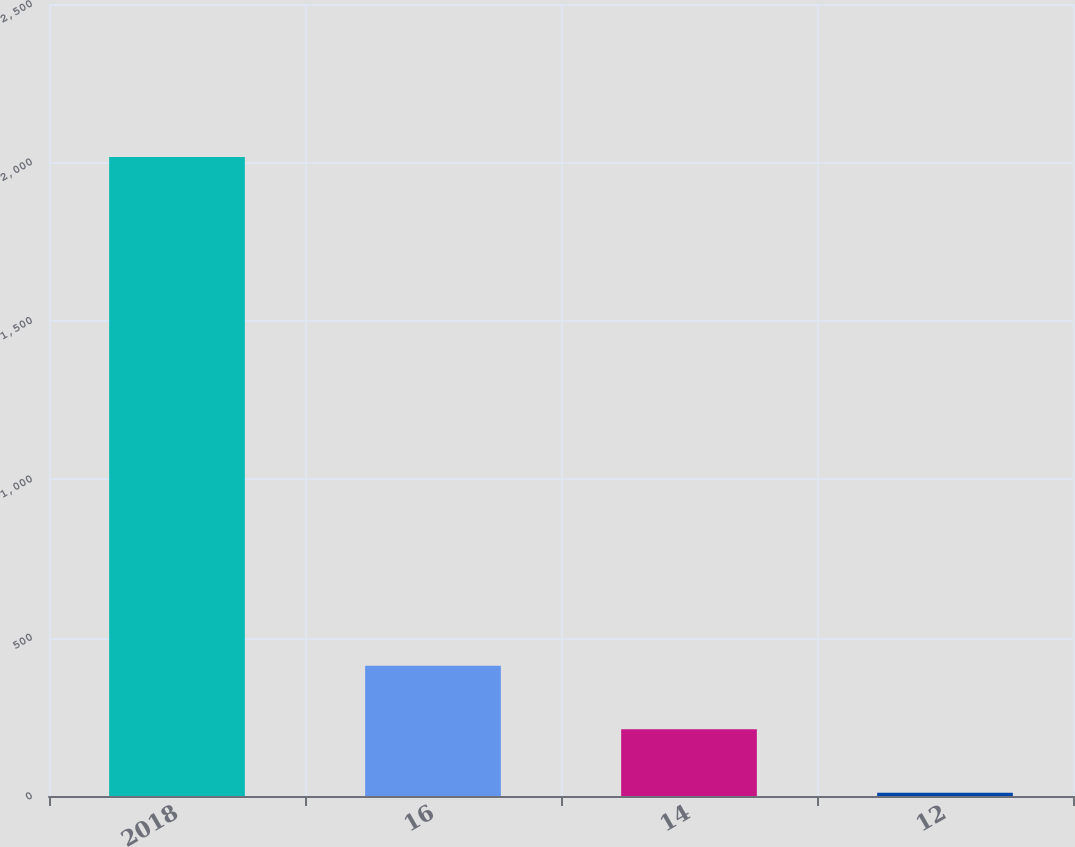<chart> <loc_0><loc_0><loc_500><loc_500><bar_chart><fcel>2018<fcel>16<fcel>14<fcel>12<nl><fcel>2017<fcel>411.4<fcel>210.7<fcel>10<nl></chart> 